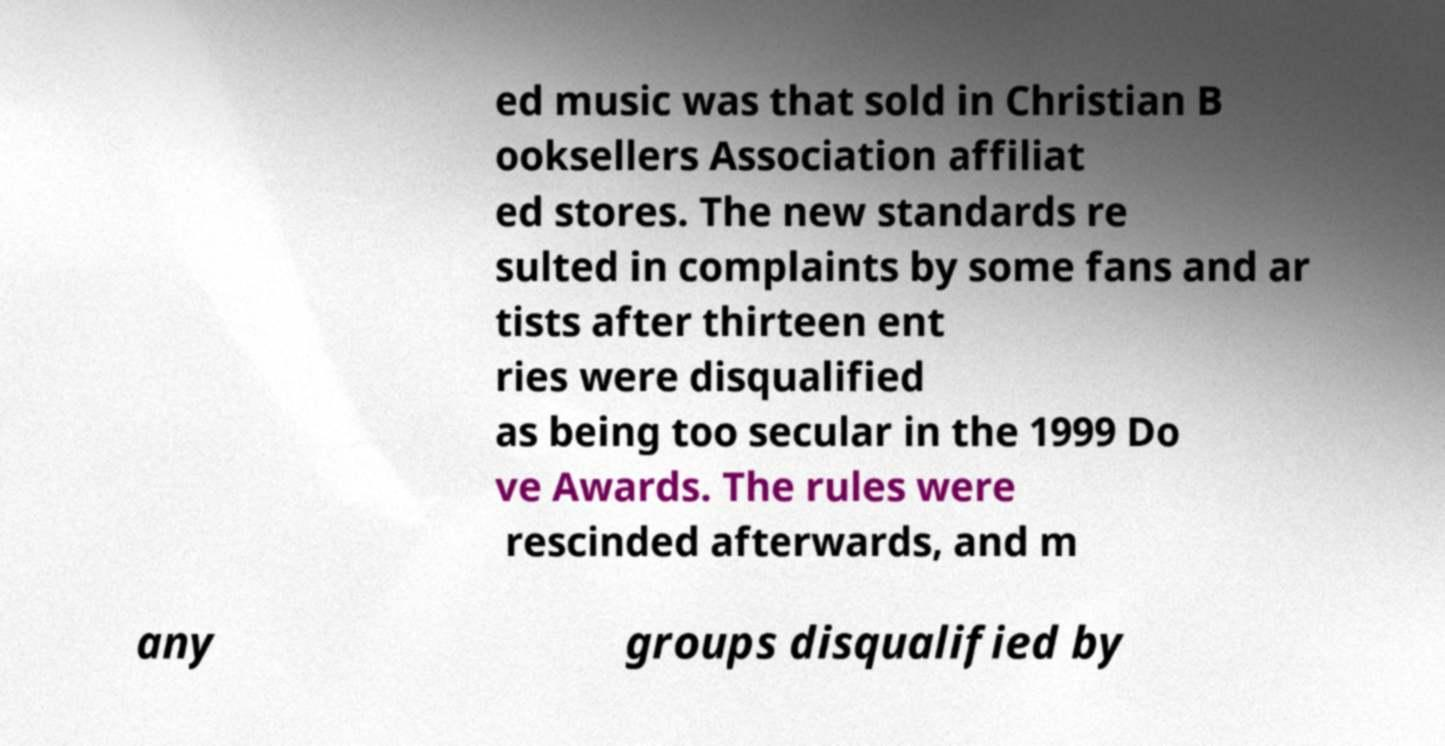There's text embedded in this image that I need extracted. Can you transcribe it verbatim? ed music was that sold in Christian B ooksellers Association affiliat ed stores. The new standards re sulted in complaints by some fans and ar tists after thirteen ent ries were disqualified as being too secular in the 1999 Do ve Awards. The rules were rescinded afterwards, and m any groups disqualified by 